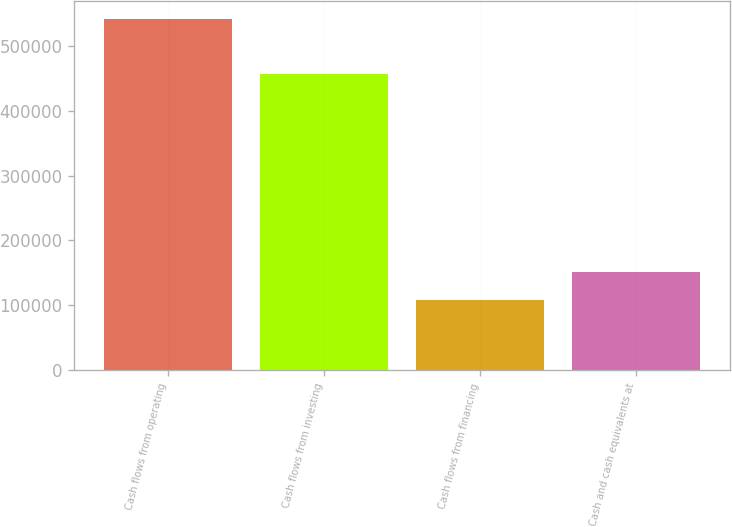Convert chart. <chart><loc_0><loc_0><loc_500><loc_500><bar_chart><fcel>Cash flows from operating<fcel>Cash flows from investing<fcel>Cash flows from financing<fcel>Cash and cash equivalents at<nl><fcel>541760<fcel>456646<fcel>108511<fcel>151836<nl></chart> 